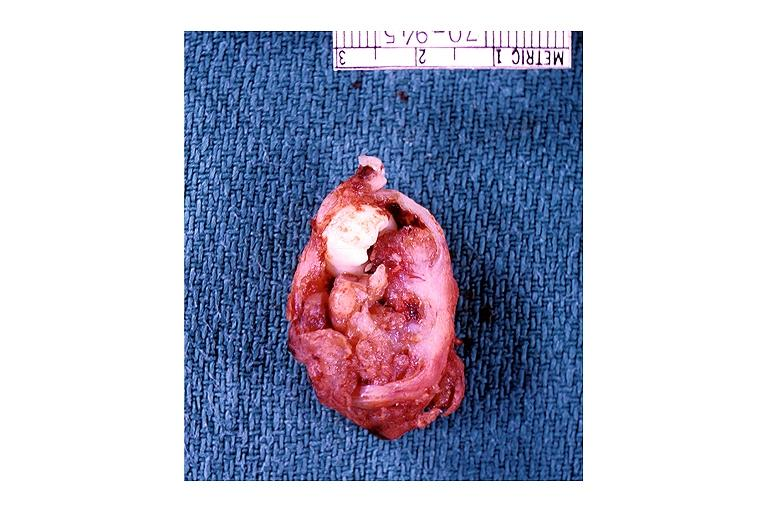what is present?
Answer the question using a single word or phrase. Oral 